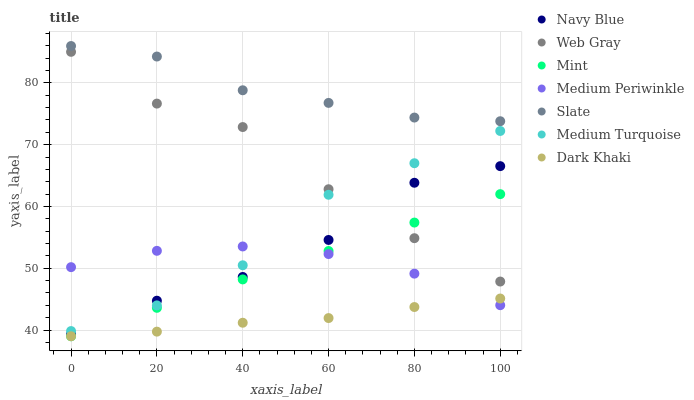Does Dark Khaki have the minimum area under the curve?
Answer yes or no. Yes. Does Slate have the maximum area under the curve?
Answer yes or no. Yes. Does Navy Blue have the minimum area under the curve?
Answer yes or no. No. Does Navy Blue have the maximum area under the curve?
Answer yes or no. No. Is Mint the smoothest?
Answer yes or no. Yes. Is Web Gray the roughest?
Answer yes or no. Yes. Is Navy Blue the smoothest?
Answer yes or no. No. Is Navy Blue the roughest?
Answer yes or no. No. Does Dark Khaki have the lowest value?
Answer yes or no. Yes. Does Navy Blue have the lowest value?
Answer yes or no. No. Does Slate have the highest value?
Answer yes or no. Yes. Does Navy Blue have the highest value?
Answer yes or no. No. Is Medium Periwinkle less than Slate?
Answer yes or no. Yes. Is Web Gray greater than Medium Periwinkle?
Answer yes or no. Yes. Does Medium Turquoise intersect Medium Periwinkle?
Answer yes or no. Yes. Is Medium Turquoise less than Medium Periwinkle?
Answer yes or no. No. Is Medium Turquoise greater than Medium Periwinkle?
Answer yes or no. No. Does Medium Periwinkle intersect Slate?
Answer yes or no. No. 